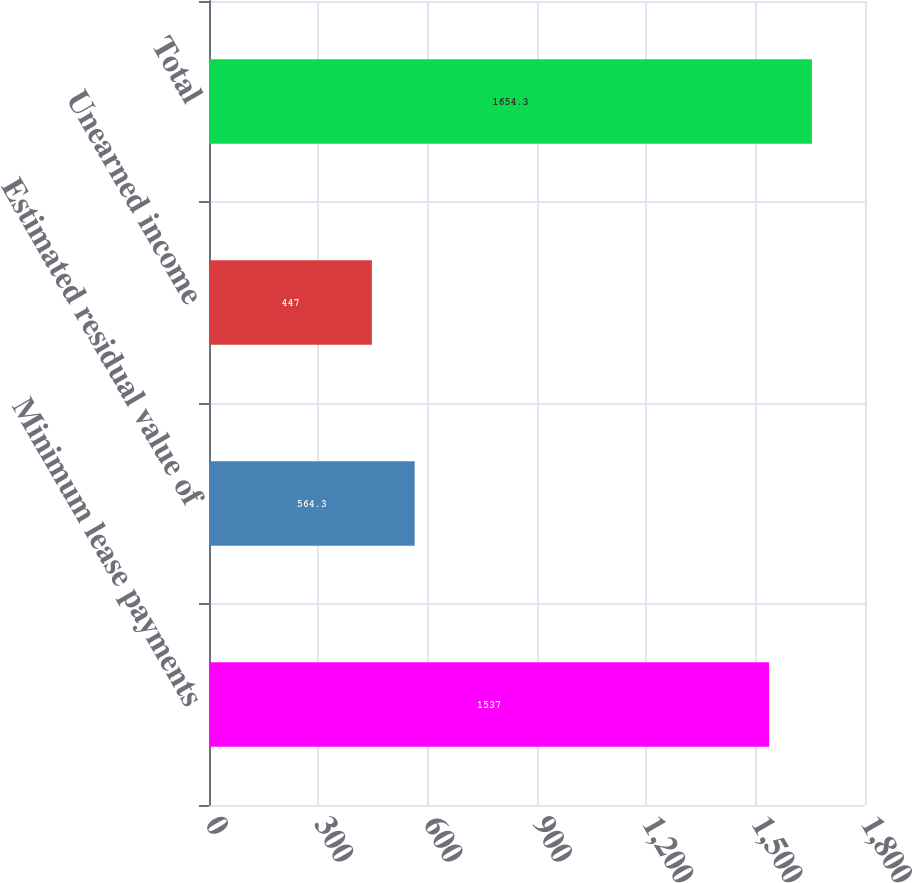Convert chart to OTSL. <chart><loc_0><loc_0><loc_500><loc_500><bar_chart><fcel>Minimum lease payments<fcel>Estimated residual value of<fcel>Unearned income<fcel>Total<nl><fcel>1537<fcel>564.3<fcel>447<fcel>1654.3<nl></chart> 